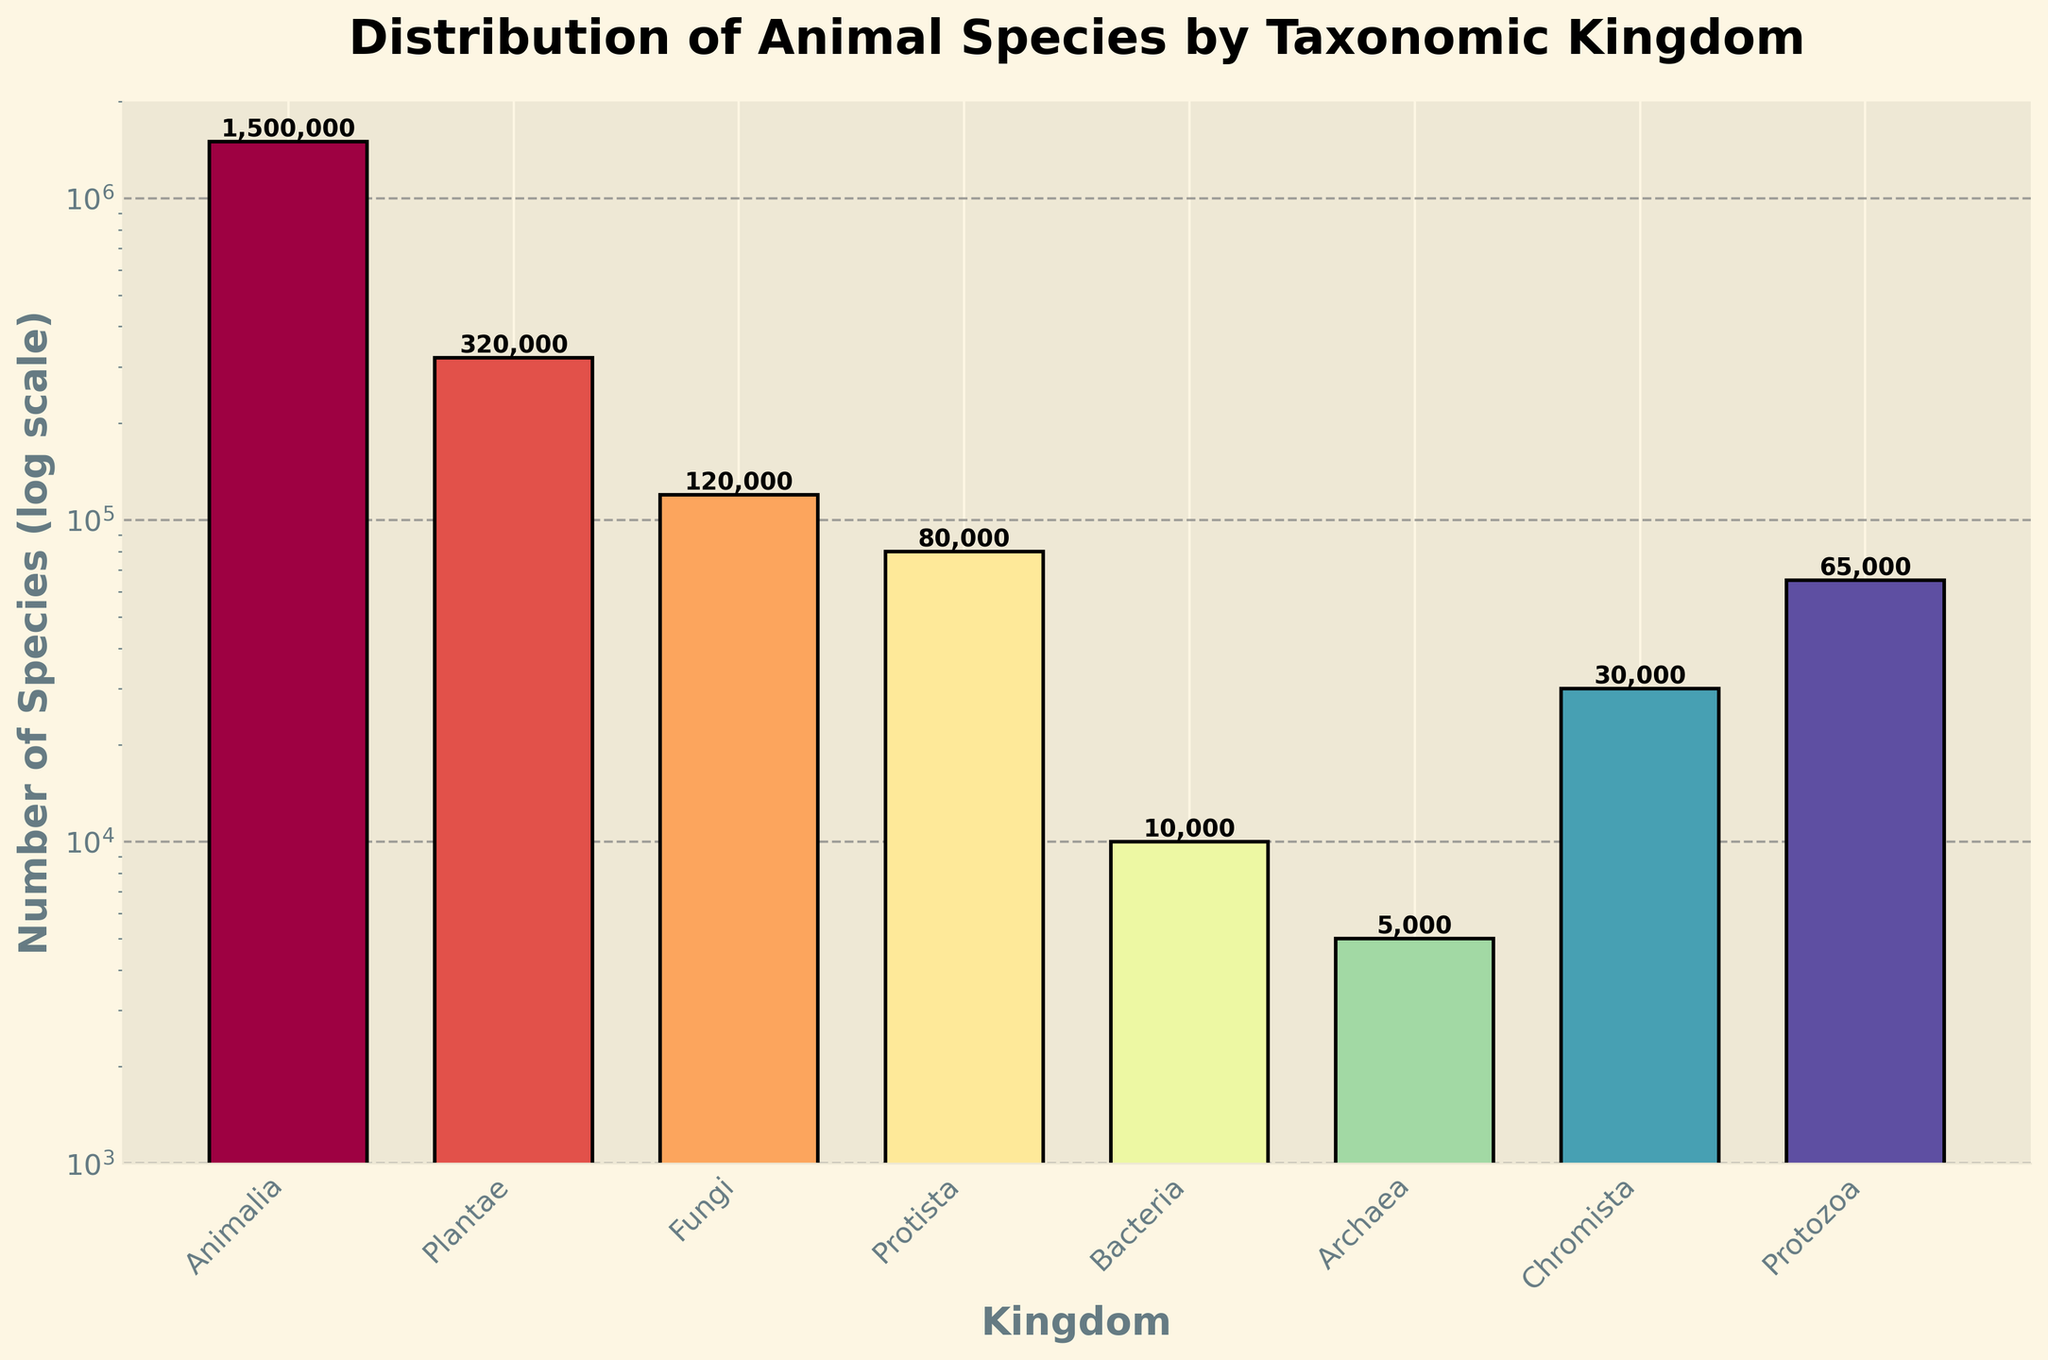What kingdom has the highest number of species? The bar representing Animalia is the tallest among all, indicating it has the highest number of species.
Answer: Animalia Which kingdom has fewer species, Fungi or Chromista? The height of the bar for Chromista is visually shorter than that for Fungi, indicating fewer species in Chromista.
Answer: Chromista By what factor do the number of species in Animalia exceed that in Plantae? Animalia has 1,500,000 species, and Plantae has 320,000 species. Dividing Animalia by Plantae gives us approximately 4.69.
Answer: 4.69 What is the total number of species in Archaea, Bacteria, and Protozoa? Adding the number of species: Archaea (5,000), Bacteria (10,000), and Protozoa (65,000) yields 80,000.
Answer: 80,000 Which kingdom shows a more significant difference from Protista, Bacteria or Plantae? Protista has 80,000 species. The difference with Bacteria is 80,000 - 10,000 = 70,000 and with Plantae is 320,000 - 80,000 = 240,000. Plantae shows a more significant difference.
Answer: Plantae Which kingdoms have a number of species that fall below the 50,000 mark? Visual inspection shows the bars for Bacteria, Archaea, Chromista, and Protozoa are within or below this mark.
Answer: Bacteria, Archaea Does the Fungi kingdom have more or fewer species than Protista and Protozoa combined? Protista (80,000) + Protozoa (65,000) = 145,000 species. Fungi has 120,000 species, which is fewer than 145,000.
Answer: Fewer Between Fungi and Chromista, which kingdom has approximately double the number of species compared to the other? Fungi has 120,000 species, and Chromista has 30,000. Fungi has four times the number of species than Chromista, so none fits the "double" criteria.
Answer: None What is the visual color representation used for Animalia? The color for the bar representing Animalia is visually distinctive and vibrant, likely from the warmer spectrum.
Answer: (A vibrant and likely warm color, say red) Is the number of species in Plantae closer to that of Animalia or Fungi? Animalia has 1,500,000 species, and Plantae has 320,000 compared to Fungi with 120,000. The difference with Animalia is 1,180,000 and with Fungi is 200,000. Plantae is closer to Fungi.
Answer: Fungi 